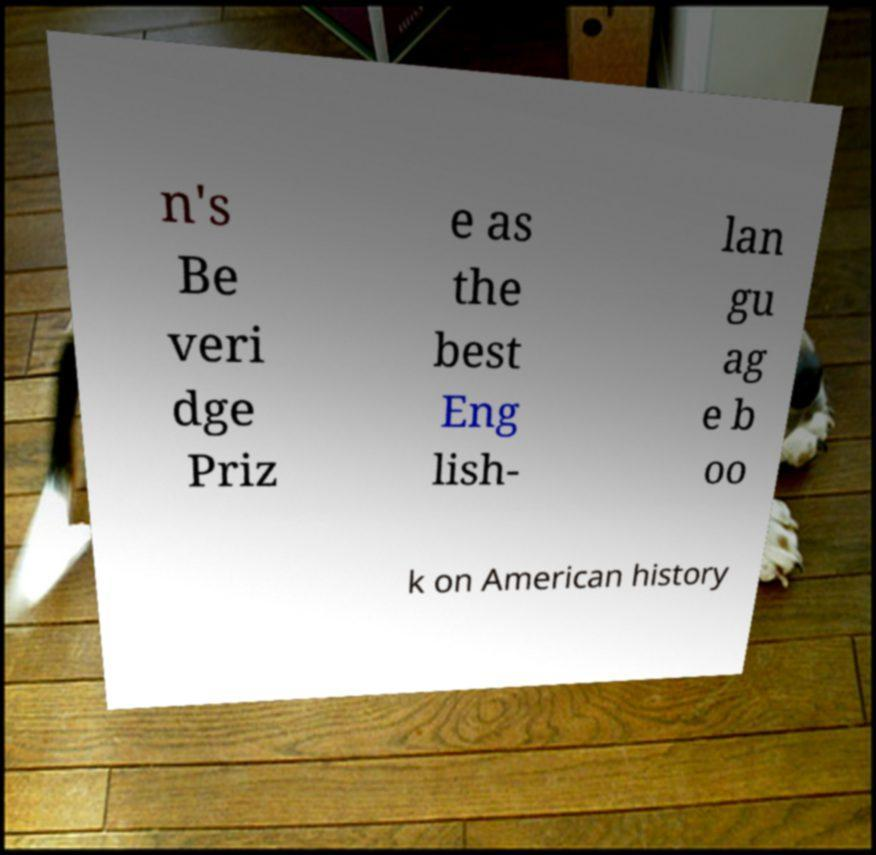There's text embedded in this image that I need extracted. Can you transcribe it verbatim? n's Be veri dge Priz e as the best Eng lish- lan gu ag e b oo k on American history 